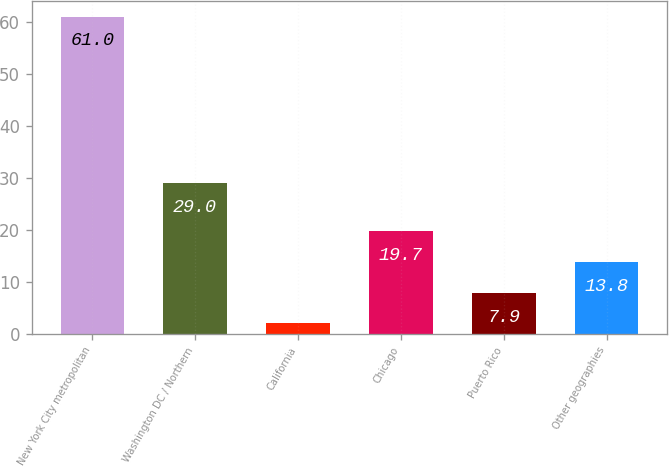Convert chart to OTSL. <chart><loc_0><loc_0><loc_500><loc_500><bar_chart><fcel>New York City metropolitan<fcel>Washington DC / Northern<fcel>California<fcel>Chicago<fcel>Puerto Rico<fcel>Other geographies<nl><fcel>61<fcel>29<fcel>2<fcel>19.7<fcel>7.9<fcel>13.8<nl></chart> 